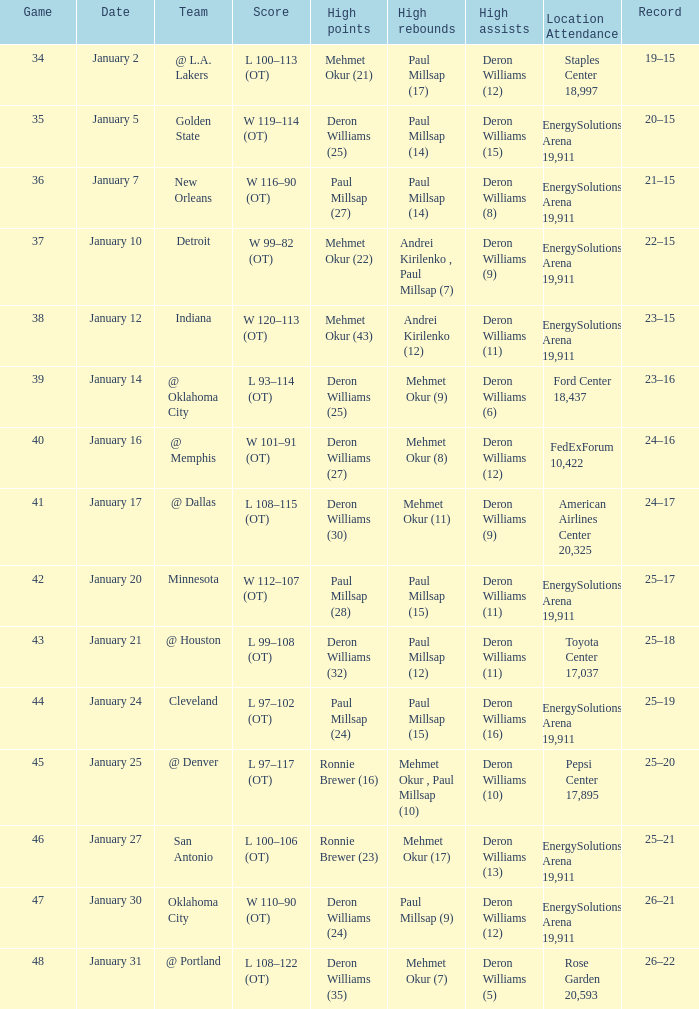Who achieved the maximum rebounds in the game when deron williams (5) had the elevated assists? Mehmet Okur (7). 